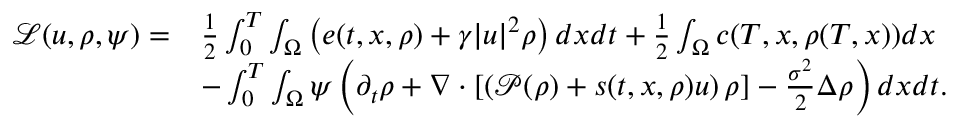<formula> <loc_0><loc_0><loc_500><loc_500>\begin{array} { r l } { \mathcal { L } ( u , \rho , \psi ) = } & { \frac { 1 } { 2 } \int _ { 0 } ^ { T } \int _ { \Omega } \left ( e ( t , x , \rho ) + \gamma | u | ^ { 2 } \rho \right ) d x d t + \frac { 1 } { 2 } \int _ { \Omega } c ( T , x , \rho ( T , x ) ) d x } \\ & { - \int _ { 0 } ^ { T } \int _ { \Omega } \psi \left ( \partial _ { t } \rho + \nabla \cdot \left [ \left ( \mathcal { P } ( \rho ) + s ( t , x , \rho ) u \right ) \rho \right ] - \frac { \sigma ^ { 2 } } { 2 } \Delta \rho \right ) d x d t . } \end{array}</formula> 